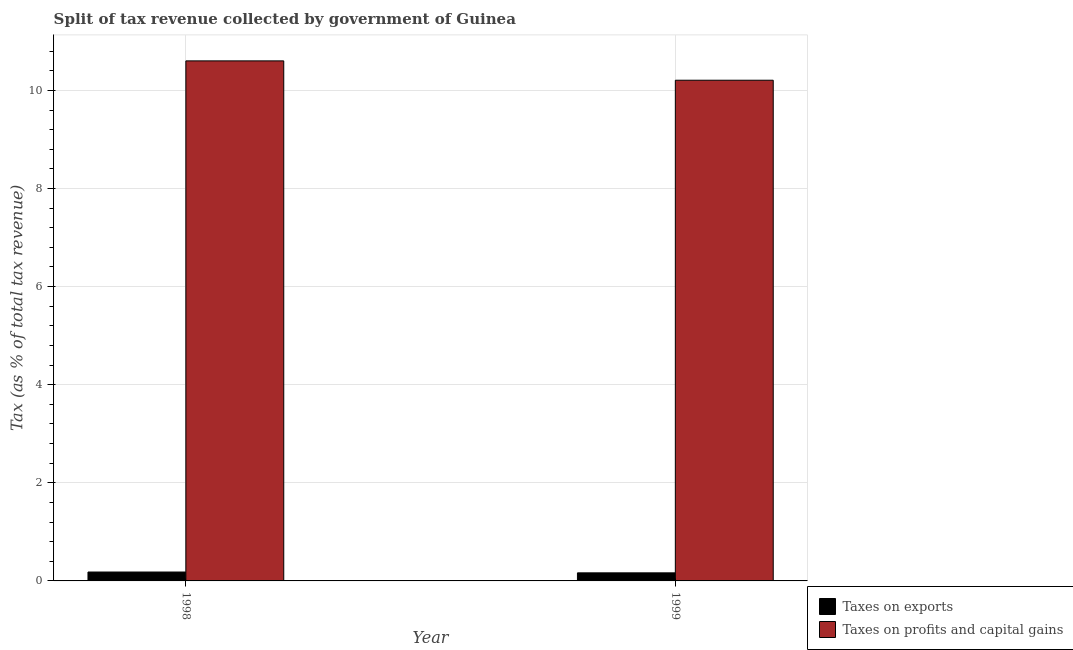How many different coloured bars are there?
Make the answer very short. 2. How many groups of bars are there?
Provide a short and direct response. 2. Are the number of bars per tick equal to the number of legend labels?
Give a very brief answer. Yes. How many bars are there on the 1st tick from the left?
Ensure brevity in your answer.  2. How many bars are there on the 2nd tick from the right?
Provide a short and direct response. 2. In how many cases, is the number of bars for a given year not equal to the number of legend labels?
Your response must be concise. 0. What is the percentage of revenue obtained from taxes on profits and capital gains in 1998?
Give a very brief answer. 10.6. Across all years, what is the maximum percentage of revenue obtained from taxes on exports?
Make the answer very short. 0.18. Across all years, what is the minimum percentage of revenue obtained from taxes on profits and capital gains?
Your answer should be very brief. 10.21. In which year was the percentage of revenue obtained from taxes on exports maximum?
Your answer should be compact. 1998. What is the total percentage of revenue obtained from taxes on exports in the graph?
Provide a succinct answer. 0.35. What is the difference between the percentage of revenue obtained from taxes on exports in 1998 and that in 1999?
Provide a short and direct response. 0.02. What is the difference between the percentage of revenue obtained from taxes on profits and capital gains in 1998 and the percentage of revenue obtained from taxes on exports in 1999?
Provide a succinct answer. 0.39. What is the average percentage of revenue obtained from taxes on profits and capital gains per year?
Provide a succinct answer. 10.4. In how many years, is the percentage of revenue obtained from taxes on exports greater than 1.6 %?
Provide a short and direct response. 0. What is the ratio of the percentage of revenue obtained from taxes on profits and capital gains in 1998 to that in 1999?
Keep it short and to the point. 1.04. In how many years, is the percentage of revenue obtained from taxes on exports greater than the average percentage of revenue obtained from taxes on exports taken over all years?
Keep it short and to the point. 1. What does the 1st bar from the left in 1999 represents?
Offer a very short reply. Taxes on exports. What does the 2nd bar from the right in 1998 represents?
Ensure brevity in your answer.  Taxes on exports. How many bars are there?
Your answer should be compact. 4. Are all the bars in the graph horizontal?
Ensure brevity in your answer.  No. What is the difference between two consecutive major ticks on the Y-axis?
Your answer should be compact. 2. How many legend labels are there?
Offer a terse response. 2. What is the title of the graph?
Make the answer very short. Split of tax revenue collected by government of Guinea. What is the label or title of the X-axis?
Provide a short and direct response. Year. What is the label or title of the Y-axis?
Your response must be concise. Tax (as % of total tax revenue). What is the Tax (as % of total tax revenue) of Taxes on exports in 1998?
Ensure brevity in your answer.  0.18. What is the Tax (as % of total tax revenue) in Taxes on profits and capital gains in 1998?
Make the answer very short. 10.6. What is the Tax (as % of total tax revenue) in Taxes on exports in 1999?
Ensure brevity in your answer.  0.16. What is the Tax (as % of total tax revenue) in Taxes on profits and capital gains in 1999?
Your answer should be very brief. 10.21. Across all years, what is the maximum Tax (as % of total tax revenue) in Taxes on exports?
Offer a very short reply. 0.18. Across all years, what is the maximum Tax (as % of total tax revenue) of Taxes on profits and capital gains?
Keep it short and to the point. 10.6. Across all years, what is the minimum Tax (as % of total tax revenue) of Taxes on exports?
Keep it short and to the point. 0.16. Across all years, what is the minimum Tax (as % of total tax revenue) in Taxes on profits and capital gains?
Your response must be concise. 10.21. What is the total Tax (as % of total tax revenue) in Taxes on exports in the graph?
Make the answer very short. 0.35. What is the total Tax (as % of total tax revenue) of Taxes on profits and capital gains in the graph?
Ensure brevity in your answer.  20.81. What is the difference between the Tax (as % of total tax revenue) in Taxes on exports in 1998 and that in 1999?
Keep it short and to the point. 0.02. What is the difference between the Tax (as % of total tax revenue) of Taxes on profits and capital gains in 1998 and that in 1999?
Provide a short and direct response. 0.39. What is the difference between the Tax (as % of total tax revenue) in Taxes on exports in 1998 and the Tax (as % of total tax revenue) in Taxes on profits and capital gains in 1999?
Provide a short and direct response. -10.03. What is the average Tax (as % of total tax revenue) in Taxes on exports per year?
Offer a terse response. 0.17. What is the average Tax (as % of total tax revenue) of Taxes on profits and capital gains per year?
Provide a succinct answer. 10.4. In the year 1998, what is the difference between the Tax (as % of total tax revenue) in Taxes on exports and Tax (as % of total tax revenue) in Taxes on profits and capital gains?
Your answer should be compact. -10.42. In the year 1999, what is the difference between the Tax (as % of total tax revenue) of Taxes on exports and Tax (as % of total tax revenue) of Taxes on profits and capital gains?
Your response must be concise. -10.04. What is the ratio of the Tax (as % of total tax revenue) in Taxes on exports in 1998 to that in 1999?
Offer a very short reply. 1.1. What is the ratio of the Tax (as % of total tax revenue) of Taxes on profits and capital gains in 1998 to that in 1999?
Offer a very short reply. 1.04. What is the difference between the highest and the second highest Tax (as % of total tax revenue) in Taxes on exports?
Make the answer very short. 0.02. What is the difference between the highest and the second highest Tax (as % of total tax revenue) of Taxes on profits and capital gains?
Keep it short and to the point. 0.39. What is the difference between the highest and the lowest Tax (as % of total tax revenue) of Taxes on exports?
Ensure brevity in your answer.  0.02. What is the difference between the highest and the lowest Tax (as % of total tax revenue) in Taxes on profits and capital gains?
Keep it short and to the point. 0.39. 